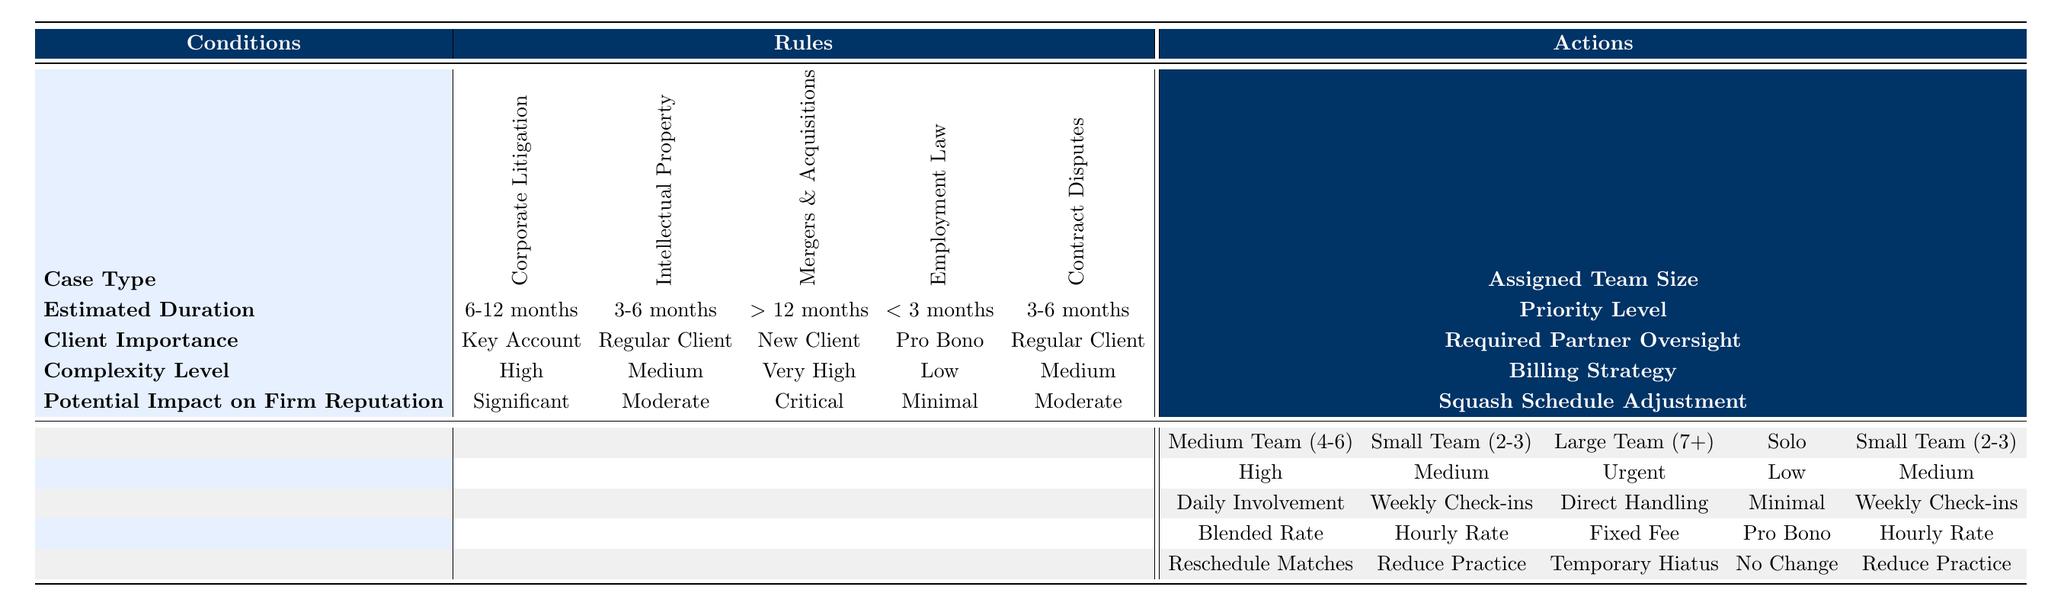What team size is assigned for a Corporate Litigation case with a key account requiring daily involvement? According to the table, for Corporate Litigation lasting 6-12 months with a key account, the assigned team size is a Medium Team (4-6) and the required partner oversight is Daily Involvement. The first matches these conditions, so the answer is Medium Team (4-6).
Answer: Medium Team (4-6) Is it true that a Pro Bono Employment Law case classified as Low complexity has no change to the squash schedule? The table indicates that for Employment Law cases under 3 months, if classified as Pro Bono and Low complexity, the action listed for squash schedule adjustment is No Change. Therefore, the statement is true.
Answer: Yes Which case type for a new client has the highest team size requirement? The table shows that for Mergers & Acquisitions with a duration of over 12 months, a new client requires a Large Team (7+) due to its Very High complexity and Critical impact. This is the highest team size requirement compared to other case types for a new client.
Answer: Mergers & Acquisitions What is the required partner oversight for Contract Disputes lasting 3-6 months with a Regular Client? The table entries for Contract Disputes lasting 3-6 months with a Regular Client indicate that the required partner oversight is Weekly Check-ins. This information is specified directly in the rules for this condition.
Answer: Weekly Check-ins Which case type requires a High priority level and has a significant impact on the firm's reputation? The Corporate Litigation case with a duration of 6-12 months, classified under Key Account, has both a High priority level and a Significant impact on the firm's reputation, according to the rules in the table.
Answer: Corporate Litigation 